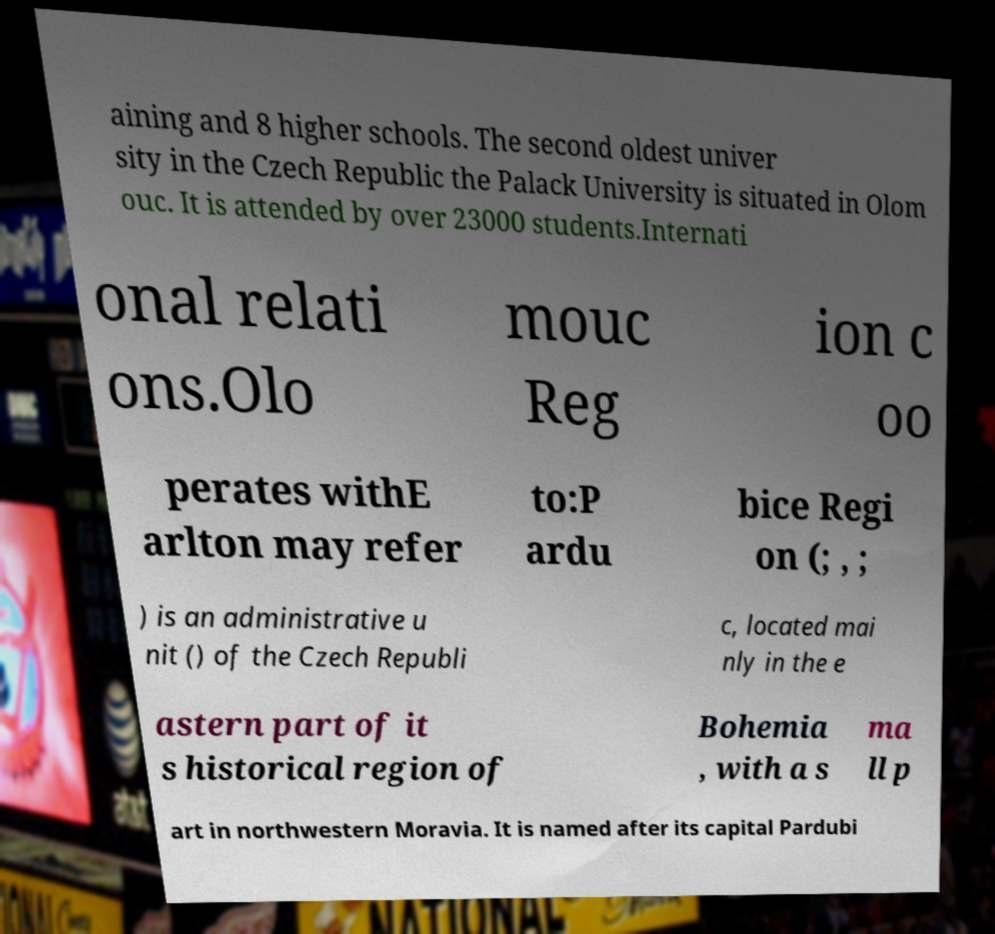What messages or text are displayed in this image? I need them in a readable, typed format. aining and 8 higher schools. The second oldest univer sity in the Czech Republic the Palack University is situated in Olom ouc. It is attended by over 23000 students.Internati onal relati ons.Olo mouc Reg ion c oo perates withE arlton may refer to:P ardu bice Regi on (; , ; ) is an administrative u nit () of the Czech Republi c, located mai nly in the e astern part of it s historical region of Bohemia , with a s ma ll p art in northwestern Moravia. It is named after its capital Pardubi 